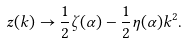<formula> <loc_0><loc_0><loc_500><loc_500>z ( k ) \rightarrow \frac { 1 } { 2 } \zeta ( \alpha ) - \frac { 1 } { 2 } \eta ( \alpha ) k ^ { 2 } .</formula> 